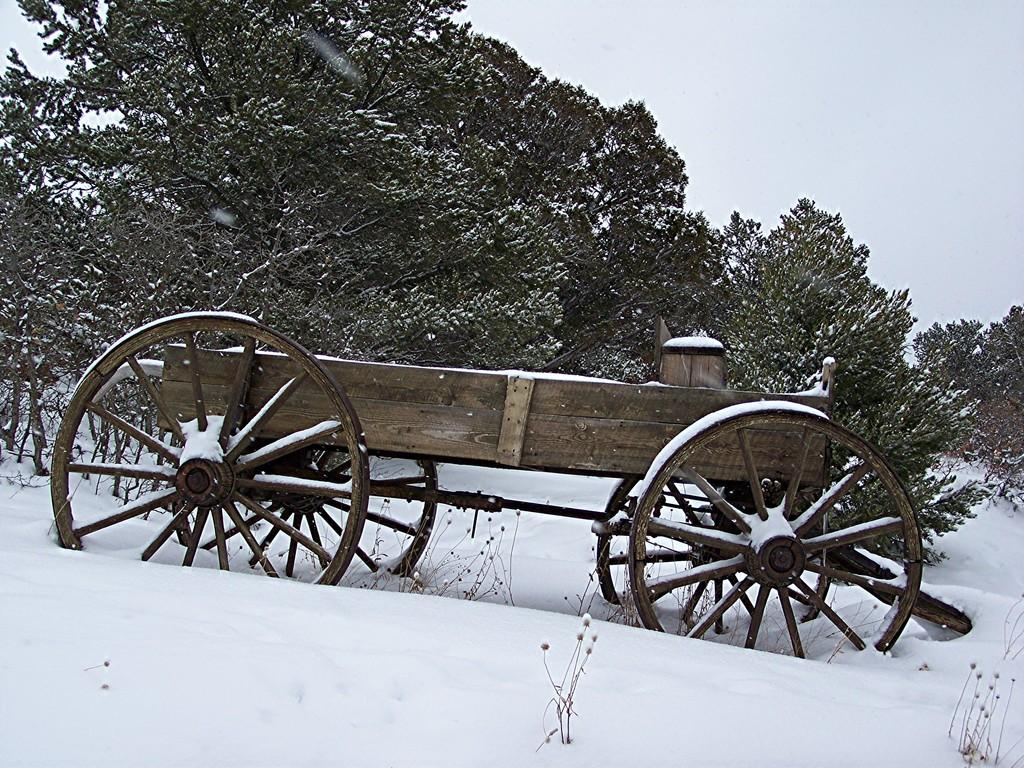What is the main object in the image? There is a cart in the image. Where is the cart located? The cart is on the snow. What can be seen in the background of the image? There are plants and trees in the background of the image. What is visible at the top of the image? The sky is visible at the top of the image. What type of jail can be seen in the image? There is no jail present in the image; it features a cart on the snow with plants, trees, and the sky in the background. What trade is being conducted in the image? There is no trade being conducted in the image; it simply shows a cart on the snow with plants, trees, and the sky in the background. 